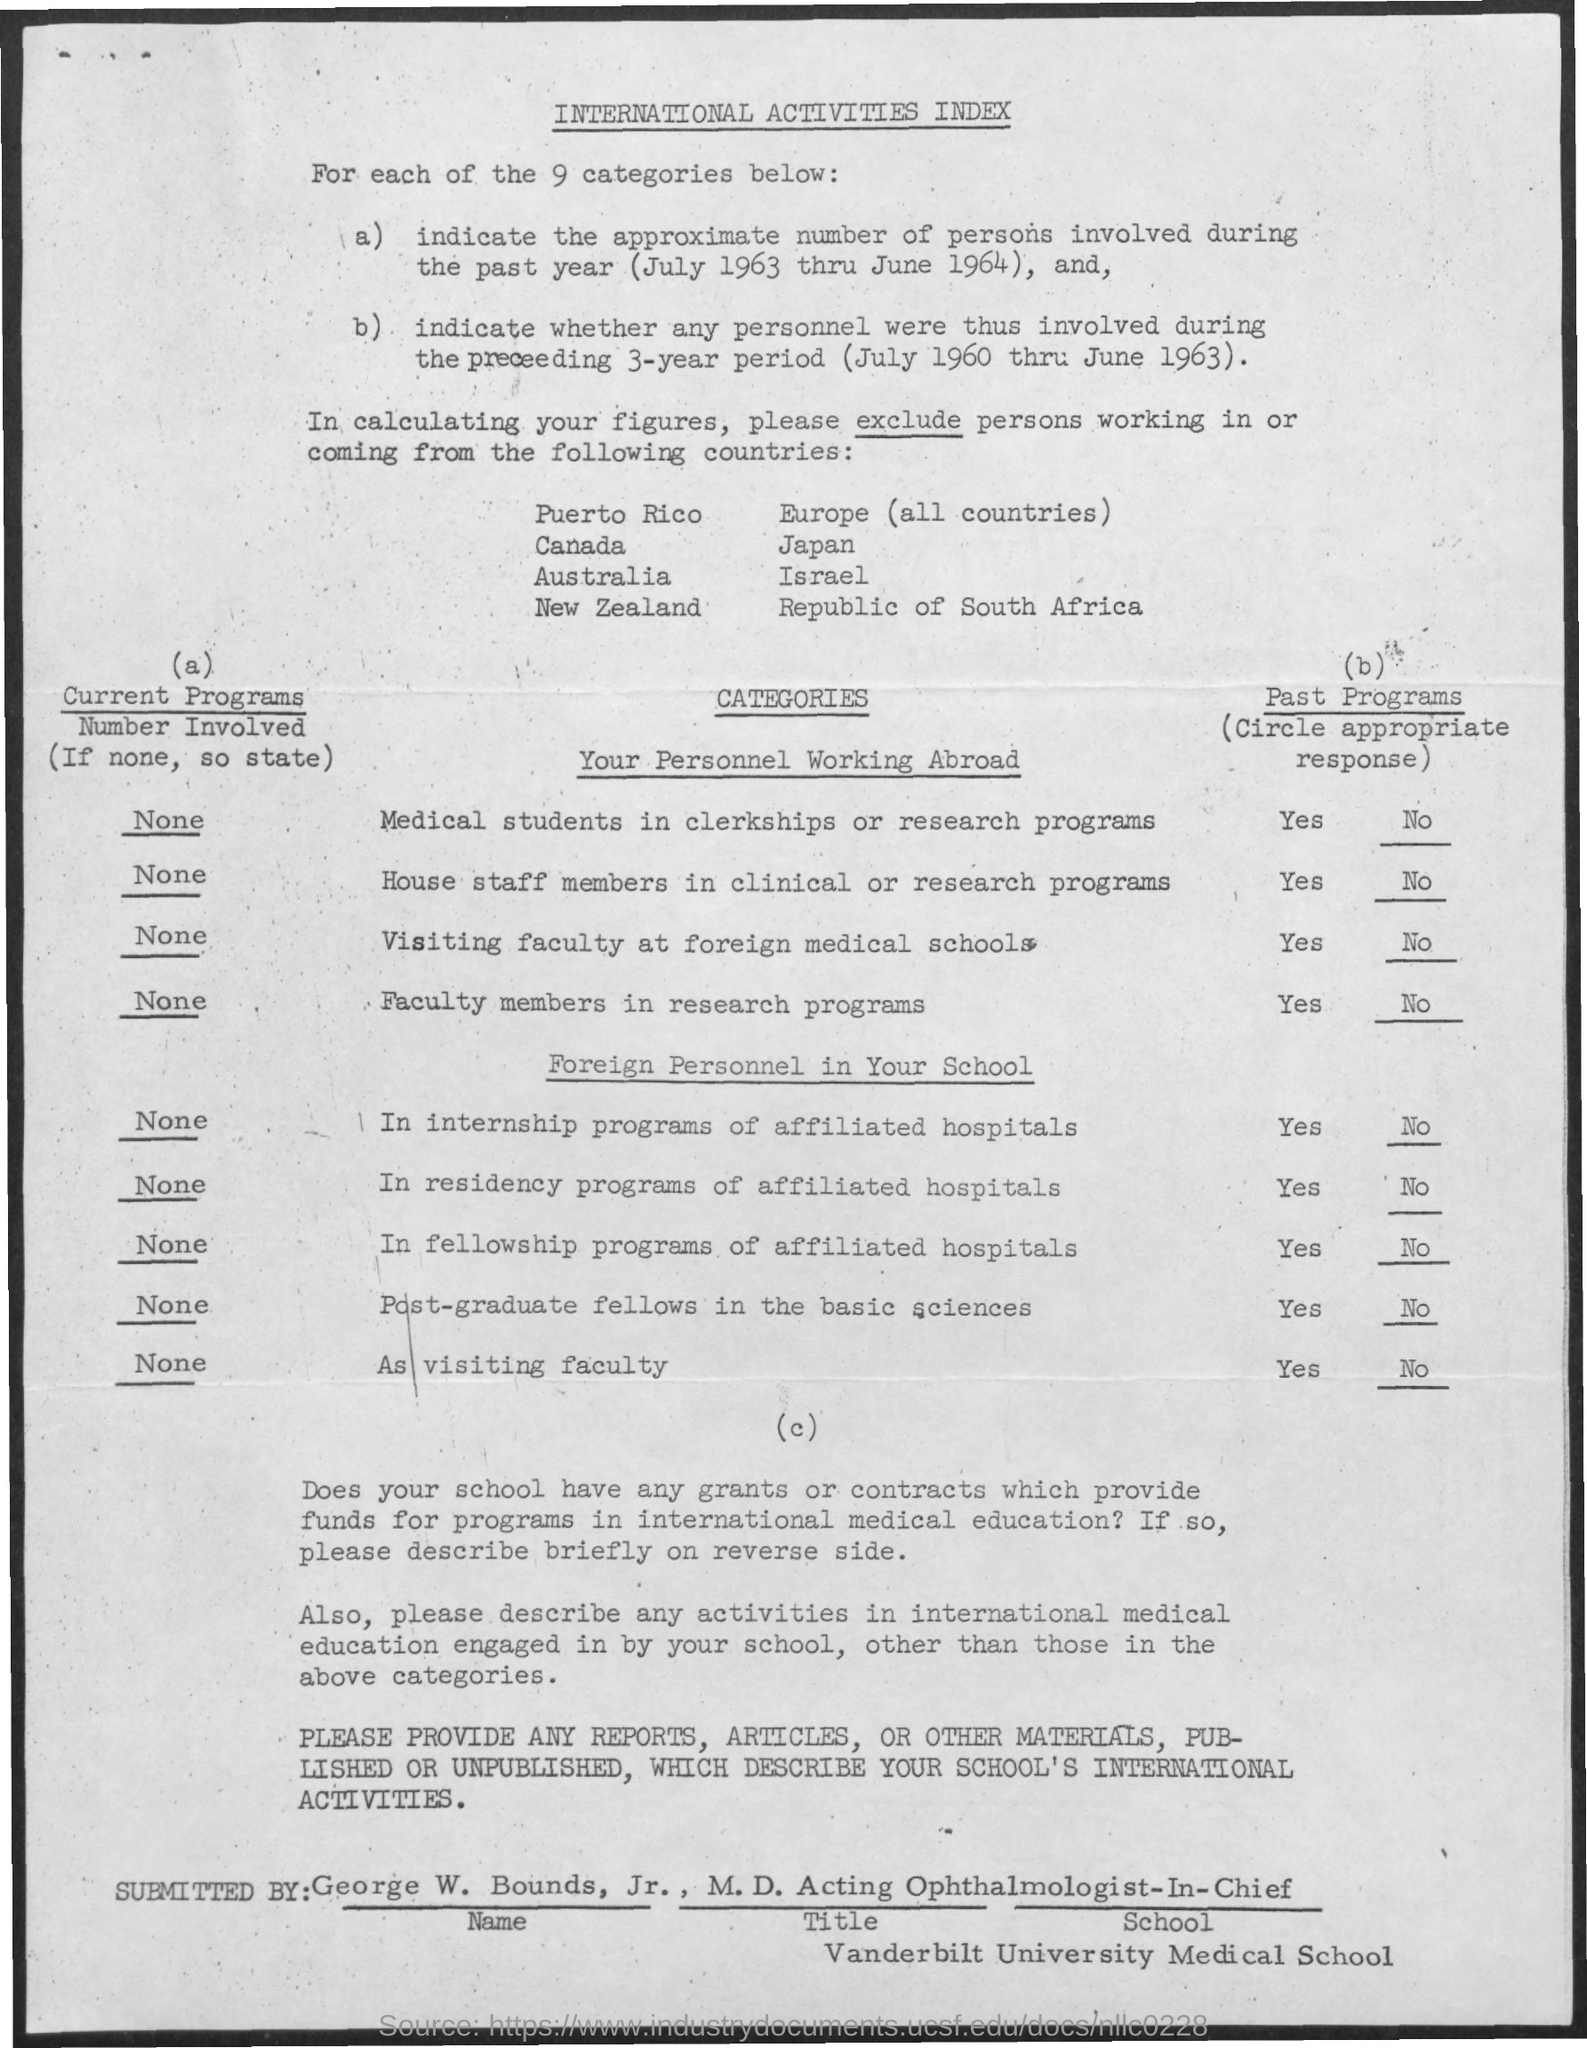What is the title of the document?
Your answer should be very brief. International activities index. How many categories are there?
Offer a terse response. 9 categories. 